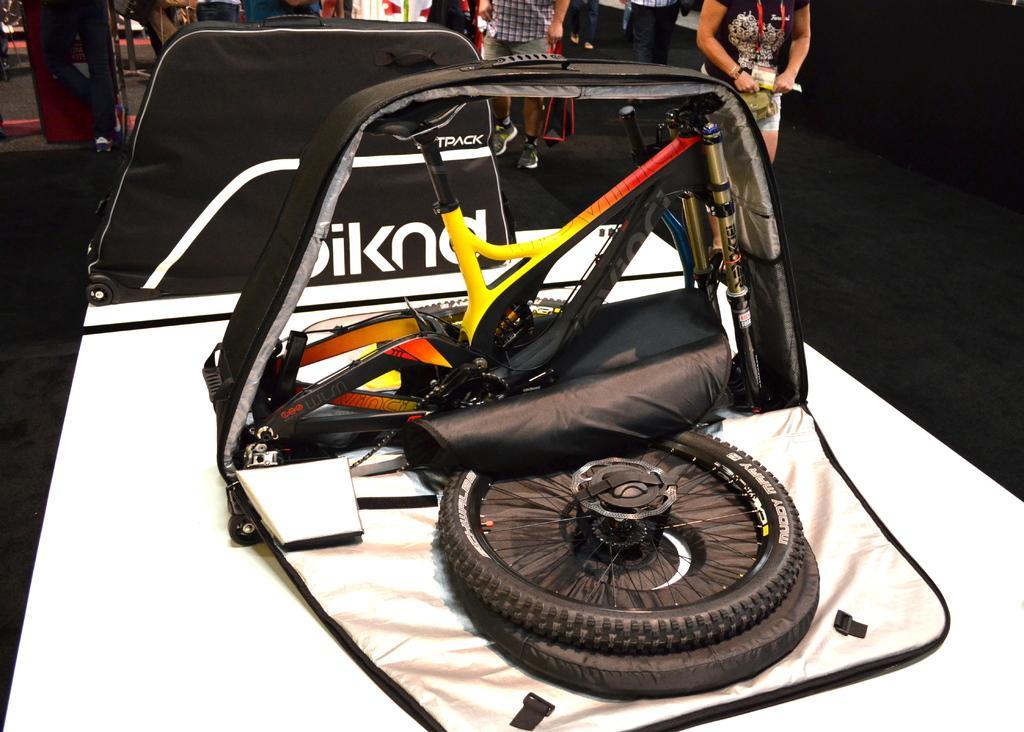How would you summarize this image in a sentence or two? There is an expo of some vehicle and behind the vehicle many people were standing. 